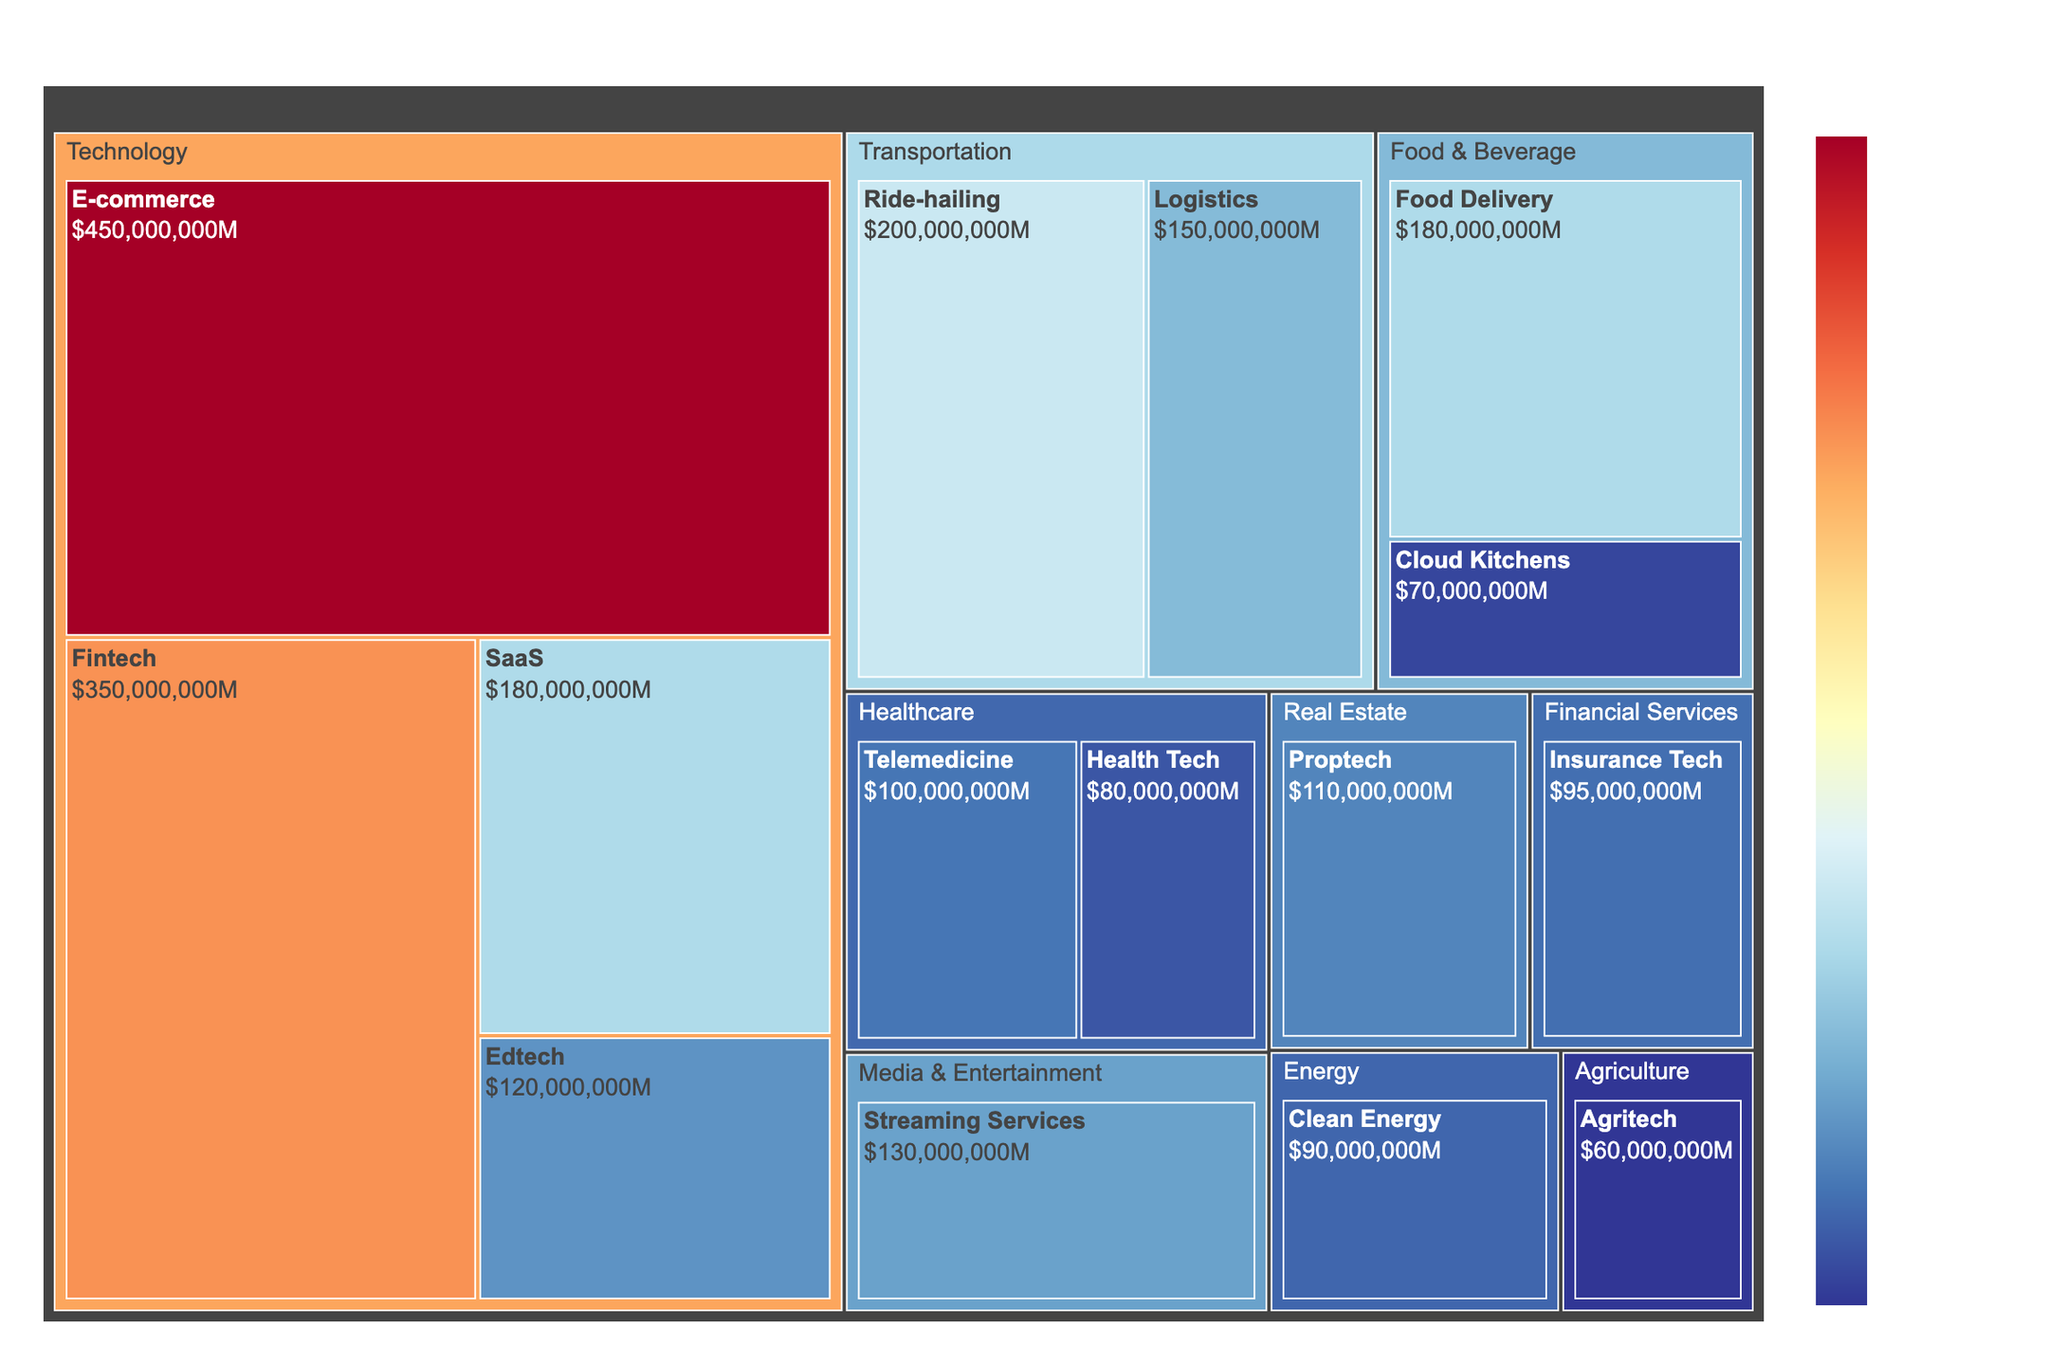What's the title of the Treemap? The title of the Treemap is easily visible at the top of the figure.
Answer: Startup Funding Distribution in Indonesia by Industry Sectors Which sector has the highest funding in the Treemap? The largest block in the Treemap represents the sector with the highest funding.
Answer: Technology How much funding does the Edtech subsector receive? By locating the Edtech subsector within the Technology sector and reading its corresponding value.
Answer: $120,000,000 What is the sum of funding for the Transportation sector? Identify the subsectors within Transportation (Ride-hailing and Logistics), sum their funding: $200,000,000 + $150,000,000.
Answer: $350,000,000 Which subsector within Healthcare has the higher funding? Compare the funding of the two subsectors within Healthcare: Telemedicine ($100,000,000) and Health Tech ($80,000,000).
Answer: Telemedicine How does the funding for Fintech compare to Streaming Services? Locate the Fintech subsector in Technology and the Streaming Services subsector in Media & Entertainment, then compare their funding values: $350,000,000 vs $130,000,000.
Answer: Fintech has more funding What is the average funding amount for the Food & Beverage sector? Sum the funding for Food Delivery and Cloud Kitchens: $180,000,000 + $70,000,000 = $250,000,000, then divide by the number of subsectors (2).
Answer: $125,000,000 Which sector has the least amount of funding? Identify the smallest block in the Treemap, which corresponds to the sector with the least funding.
Answer: Agriculture How much more funding does E-commerce have than Agritech? Subtract the funding for Agritech from E-commerce: $450,000,000 - $60,000,000.
Answer: $390,000,000 Is the funding for Ride-hailing greater than the combined funding for Agritech and Clean Energy? Compare the funding for Ride-hailing ($200,000,000) with the sum of Agritech and Clean Energy: $60,000,000 + $90,000,000 = $150,000,000.
Answer: Yes 